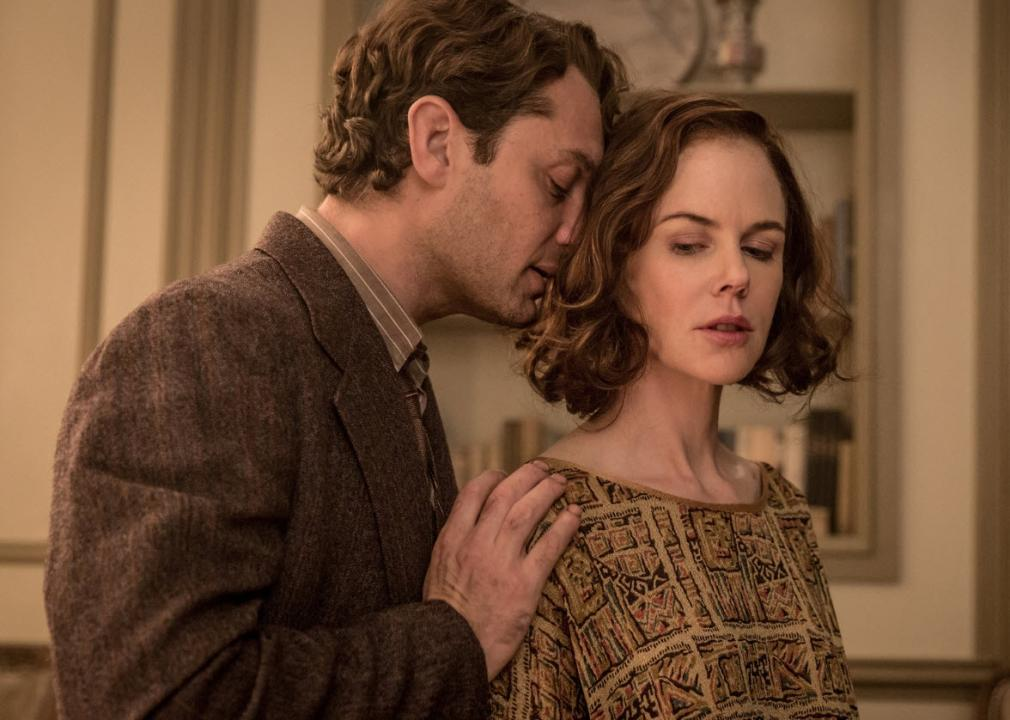How does the setting of the room contribute to the atmosphere of the scene? The room's cream-colored walls and framed pictures provide a subtle, sophisticated backdrop. The soft lighting and vintage decor enhance the historical setting of the scene. Such an environment suggests a place of privacy and intellectualism, perhaps a personal library or study, which aligns with the themes of literary exploration and intimate personal discussions that are central to the film. 